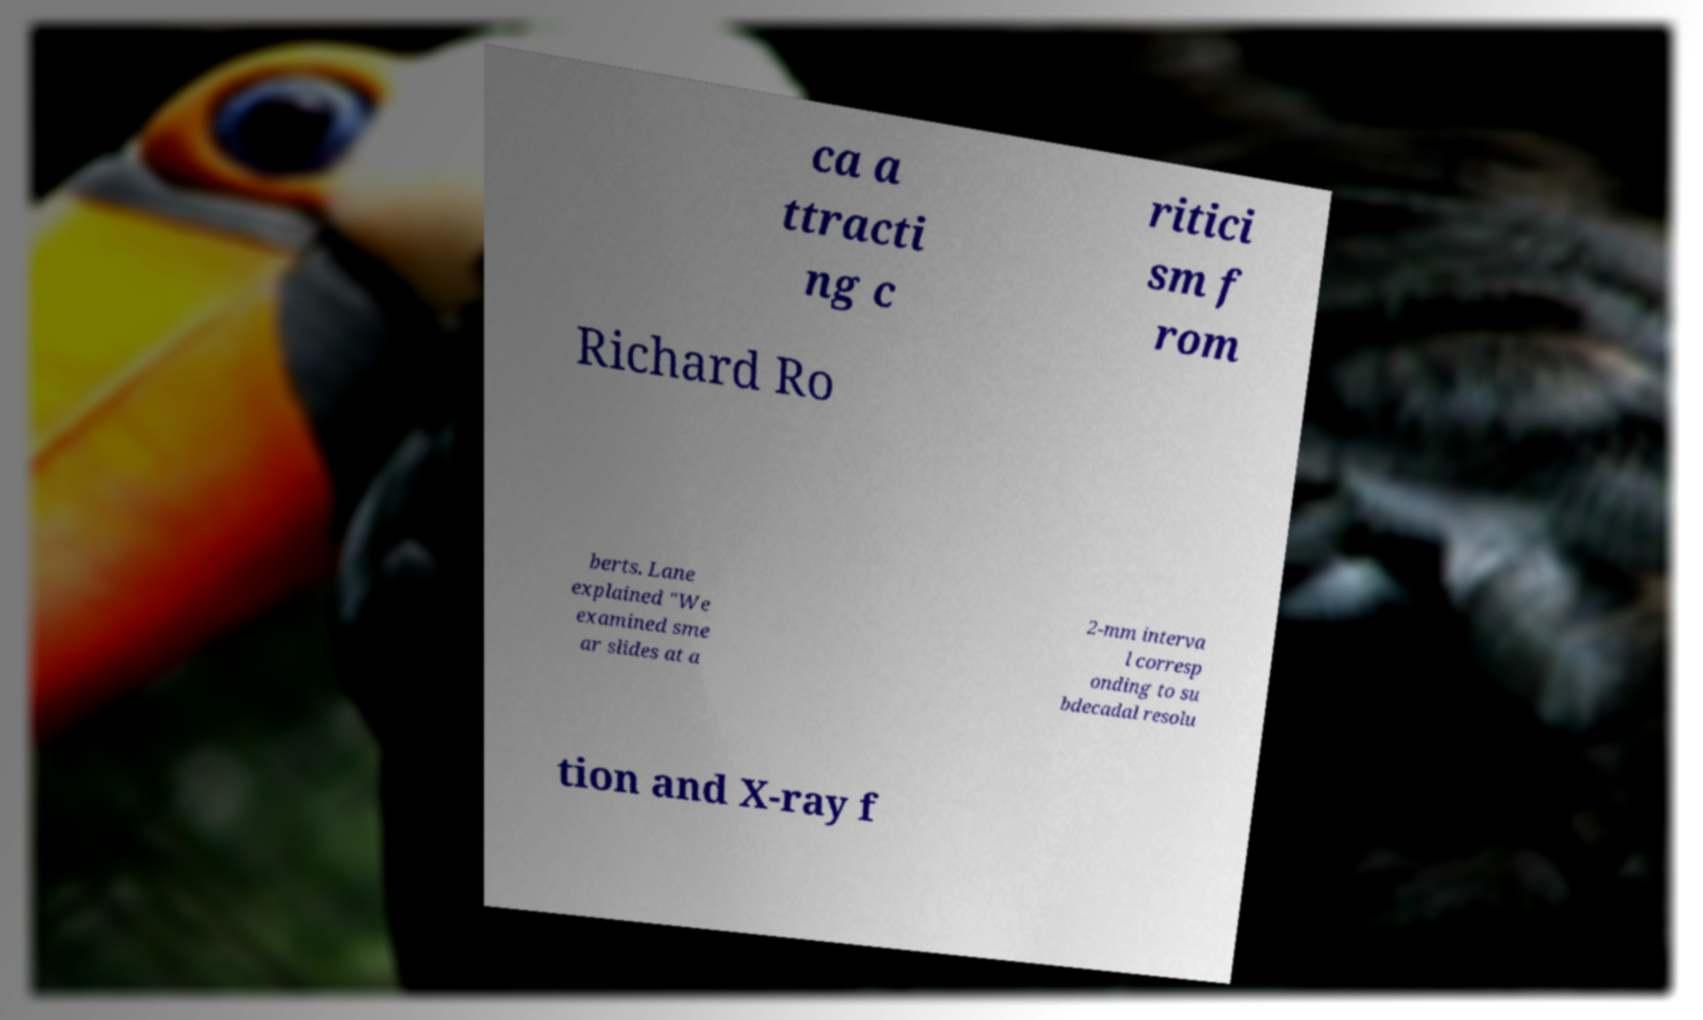Can you accurately transcribe the text from the provided image for me? ca a ttracti ng c ritici sm f rom Richard Ro berts. Lane explained "We examined sme ar slides at a 2-mm interva l corresp onding to su bdecadal resolu tion and X-ray f 